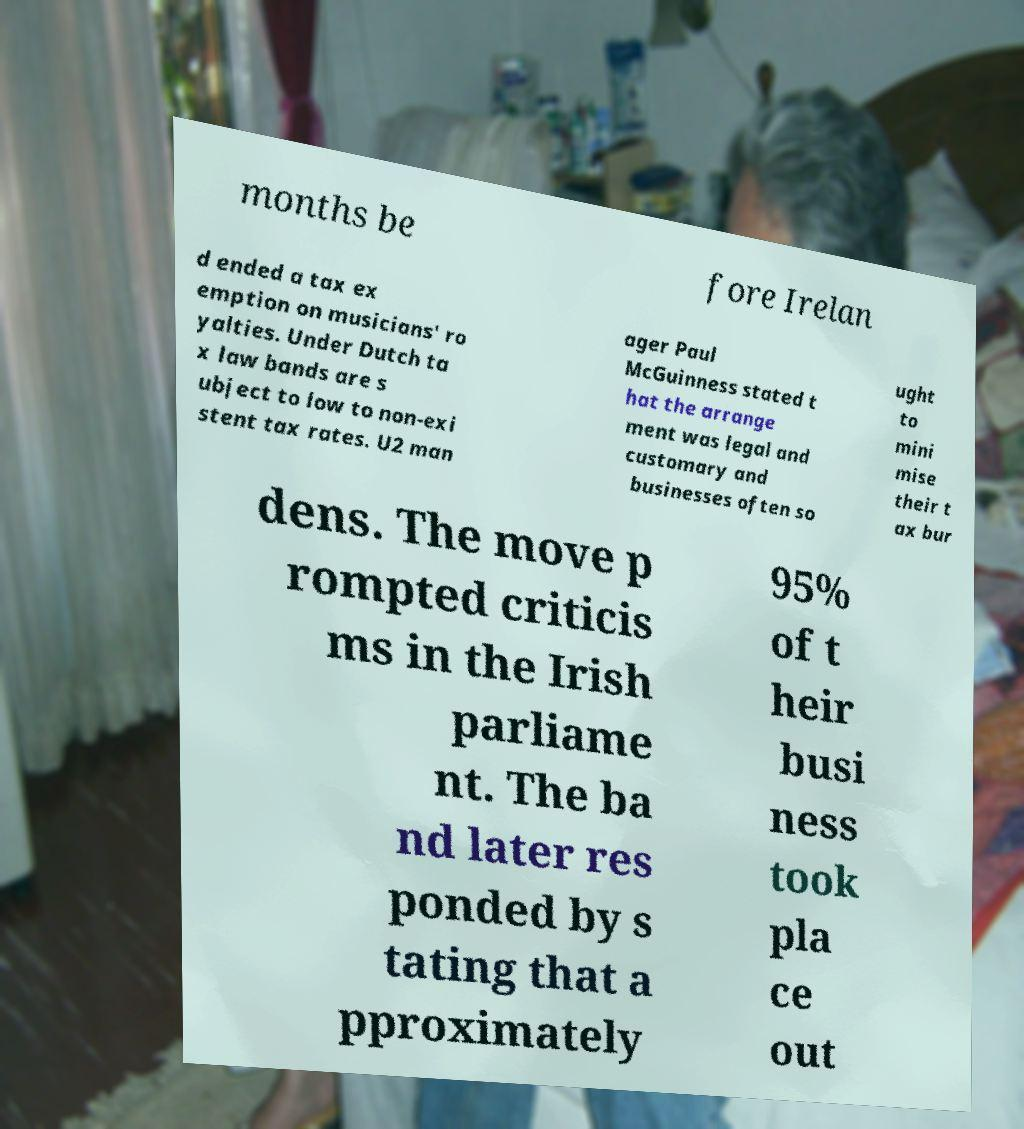What messages or text are displayed in this image? I need them in a readable, typed format. months be fore Irelan d ended a tax ex emption on musicians' ro yalties. Under Dutch ta x law bands are s ubject to low to non-exi stent tax rates. U2 man ager Paul McGuinness stated t hat the arrange ment was legal and customary and businesses often so ught to mini mise their t ax bur dens. The move p rompted criticis ms in the Irish parliame nt. The ba nd later res ponded by s tating that a pproximately 95% of t heir busi ness took pla ce out 